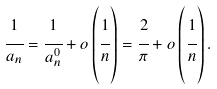<formula> <loc_0><loc_0><loc_500><loc_500>\cfrac { 1 } { a _ { n } } = \cfrac { 1 } { a _ { n } ^ { 0 } } + o \left ( \cfrac { 1 } { n } \right ) = \cfrac { 2 } { \pi } + o \left ( \cfrac { 1 } { n } \right ) .</formula> 